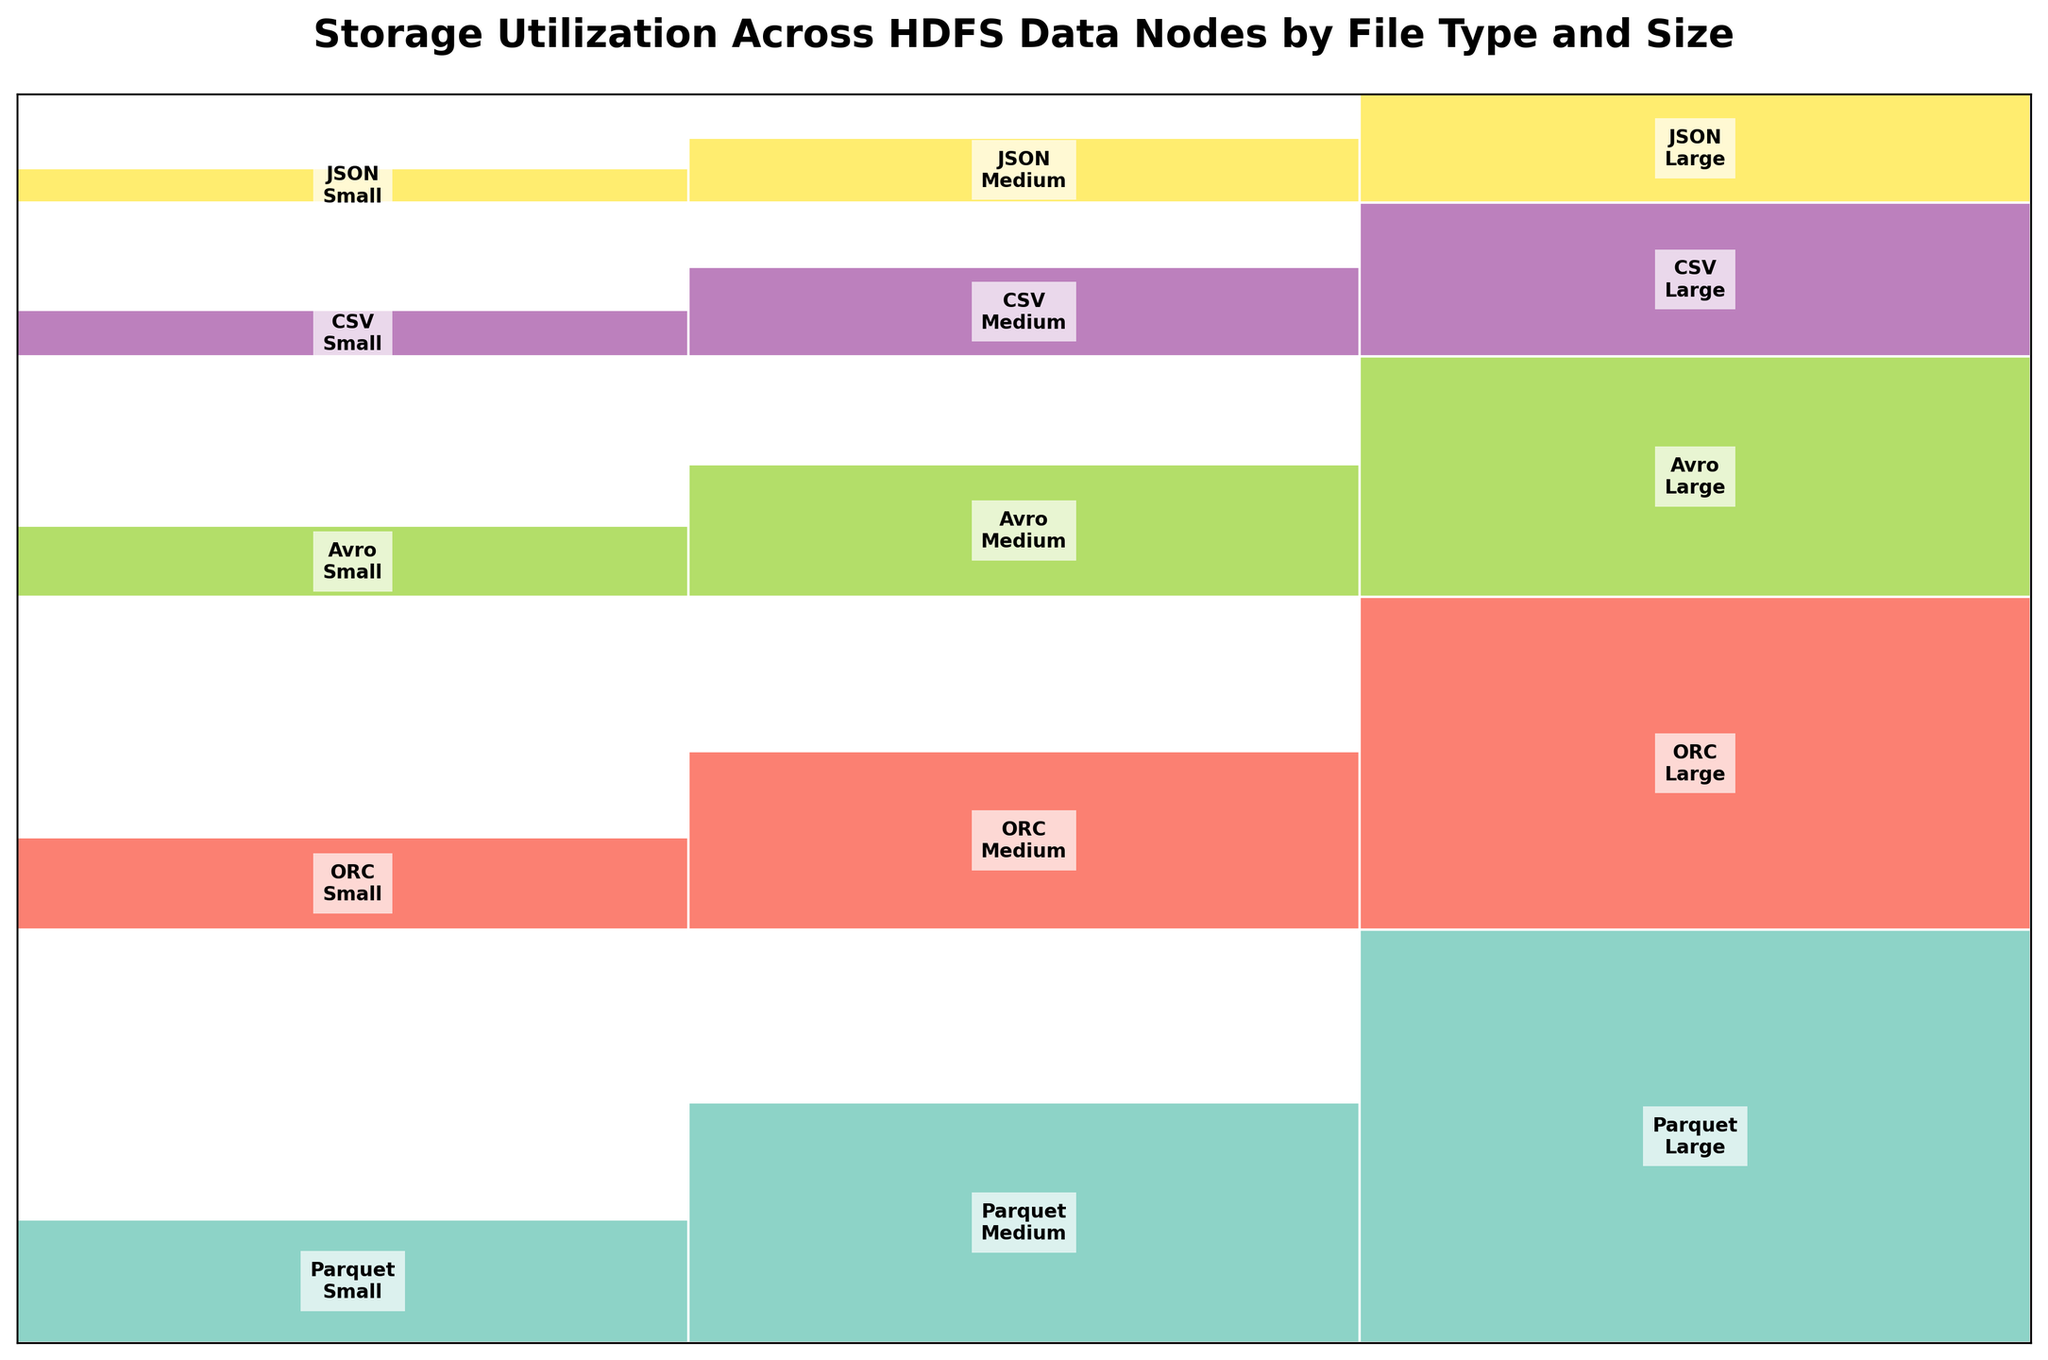How many file types are represented in the plot? The figure uses different colors to represent various file types. Count the number of unique colors representing each file type in the legend or within the plot itself.
Answer: 5 What is the title of the plot? The title is usually displayed at the top of the figure. Look for the largest, bold text summarizing what the plot represents.
Answer: Storage Utilization Across HDFS Data Nodes by File Type and Size Which file type has the smallest representation for the "Large" size range? Observe the "Large" size range category in the plot and compare the smallest height among the different file types.
Answer: JSON Comparing the "Medium" size range, which file type utilizes more storage: ORC or Avro? Look at the "Medium" size range category for both ORC and Avro. Compare the heights of the respective bars to determine which one is taller.
Answer: ORC What is the total storage utilization for CSV files across all size ranges on Node_1? Add together the heights of bars representing CSV files in the "Small", "Medium", and "Large" size ranges on Node_1.
Answer: 245 For the "Small" size range, which data node has the highest storage utilization? Look at the "Small" size range category and compare the heights of the bars on Node_1, Node_2, and Node_3. Identify the node with the tallest bar.
Answer: Node_1 How does the storage utilization for Avro files in the "Large" size range compare across Node_3 and Node_1? Compare the heights of the bars representing Avro files in the "Large" size range on both Node_3 and Node_1 to determine which is greater.
Answer: Node_1 What is the total storage utilization for all file types in the "Medium" size range across Node_2? Sum the heights of bars representing all file types in the "Medium" size range on Node_2.
Answer: 665 If you combine the storage utilization of JSON files in the "Small" and "Medium" size ranges on Node_3, what would be the total? Add the heights of the bars representing JSON files in the "Small" and "Medium" size ranges on Node_3.
Answer: 81 Which file type has the most even distribution across nodes in the "Large" size range? Compare the differences in height across nodes for each file type in the "Large" size range and identify the one with the smallest variation.
Answer: Parquet 